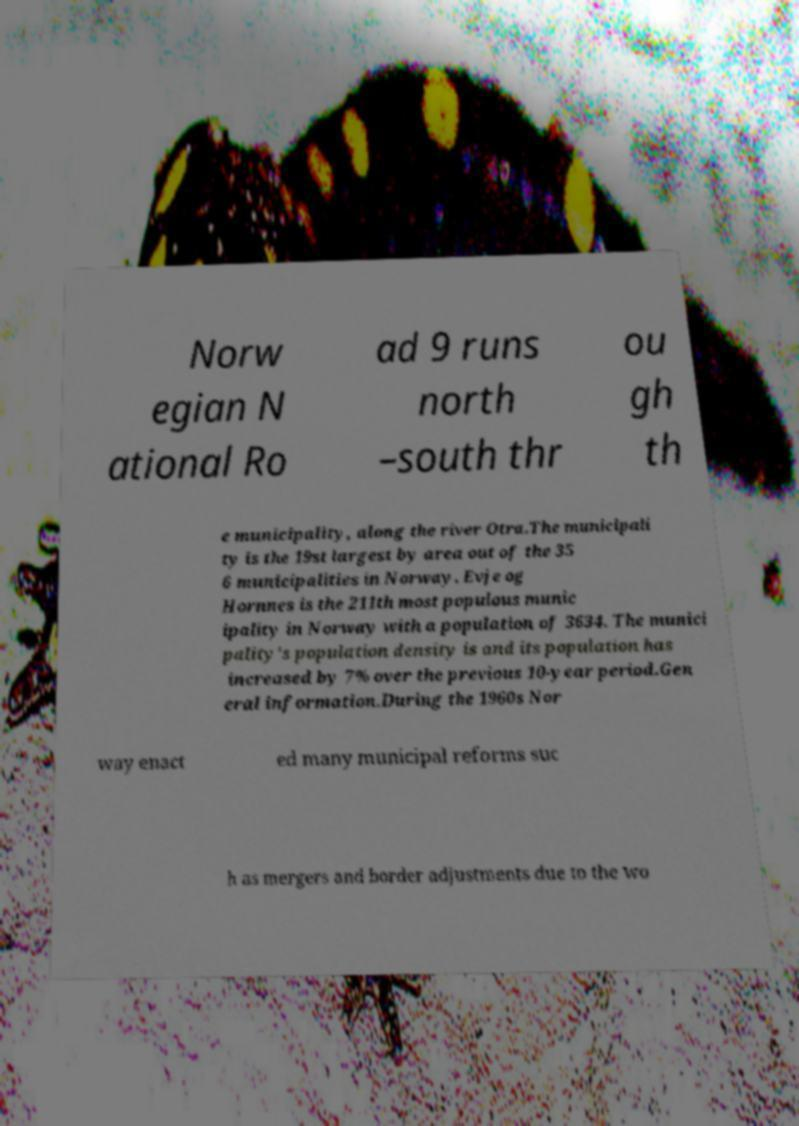Can you accurately transcribe the text from the provided image for me? Norw egian N ational Ro ad 9 runs north –south thr ou gh th e municipality, along the river Otra.The municipali ty is the 19st largest by area out of the 35 6 municipalities in Norway. Evje og Hornnes is the 211th most populous munic ipality in Norway with a population of 3634. The munici pality's population density is and its population has increased by 7% over the previous 10-year period.Gen eral information.During the 1960s Nor way enact ed many municipal reforms suc h as mergers and border adjustments due to the wo 